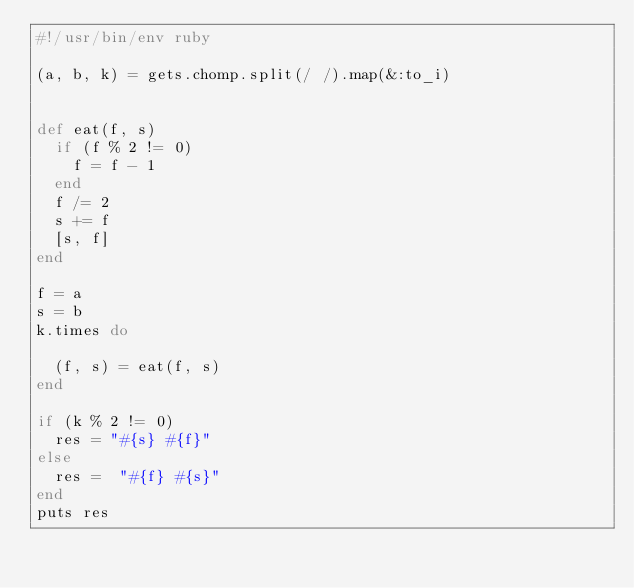<code> <loc_0><loc_0><loc_500><loc_500><_Ruby_>#!/usr/bin/env ruby

(a, b, k) = gets.chomp.split(/ /).map(&:to_i)


def eat(f, s)
  if (f % 2 != 0)
    f = f - 1
  end
  f /= 2
  s += f
  [s, f]
end

f = a
s = b
k.times do

  (f, s) = eat(f, s)
end

if (k % 2 != 0)
  res = "#{s} #{f}"
else
  res =  "#{f} #{s}"
end
puts res</code> 